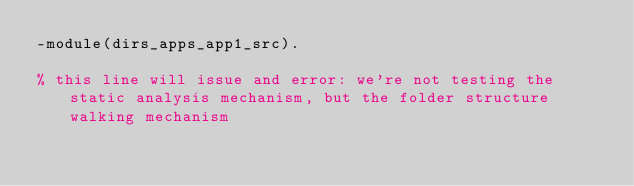Convert code to text. <code><loc_0><loc_0><loc_500><loc_500><_Erlang_>-module(dirs_apps_app1_src).

% this line will issue and error: we're not testing the static analysis mechanism, but the folder structure walking mechanism
</code> 